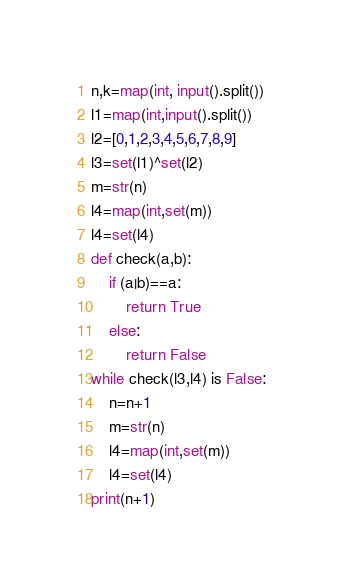Convert code to text. <code><loc_0><loc_0><loc_500><loc_500><_Python_>n,k=map(int, input().split())
l1=map(int,input().split())
l2=[0,1,2,3,4,5,6,7,8,9]
l3=set(l1)^set(l2)
m=str(n)
l4=map(int,set(m))
l4=set(l4)
def check(a,b):
    if (a|b)==a:
        return True
    else:
        return False
while check(l3,l4) is False:
    n=n+1
    m=str(n)
    l4=map(int,set(m))
    l4=set(l4)
print(n+1)</code> 